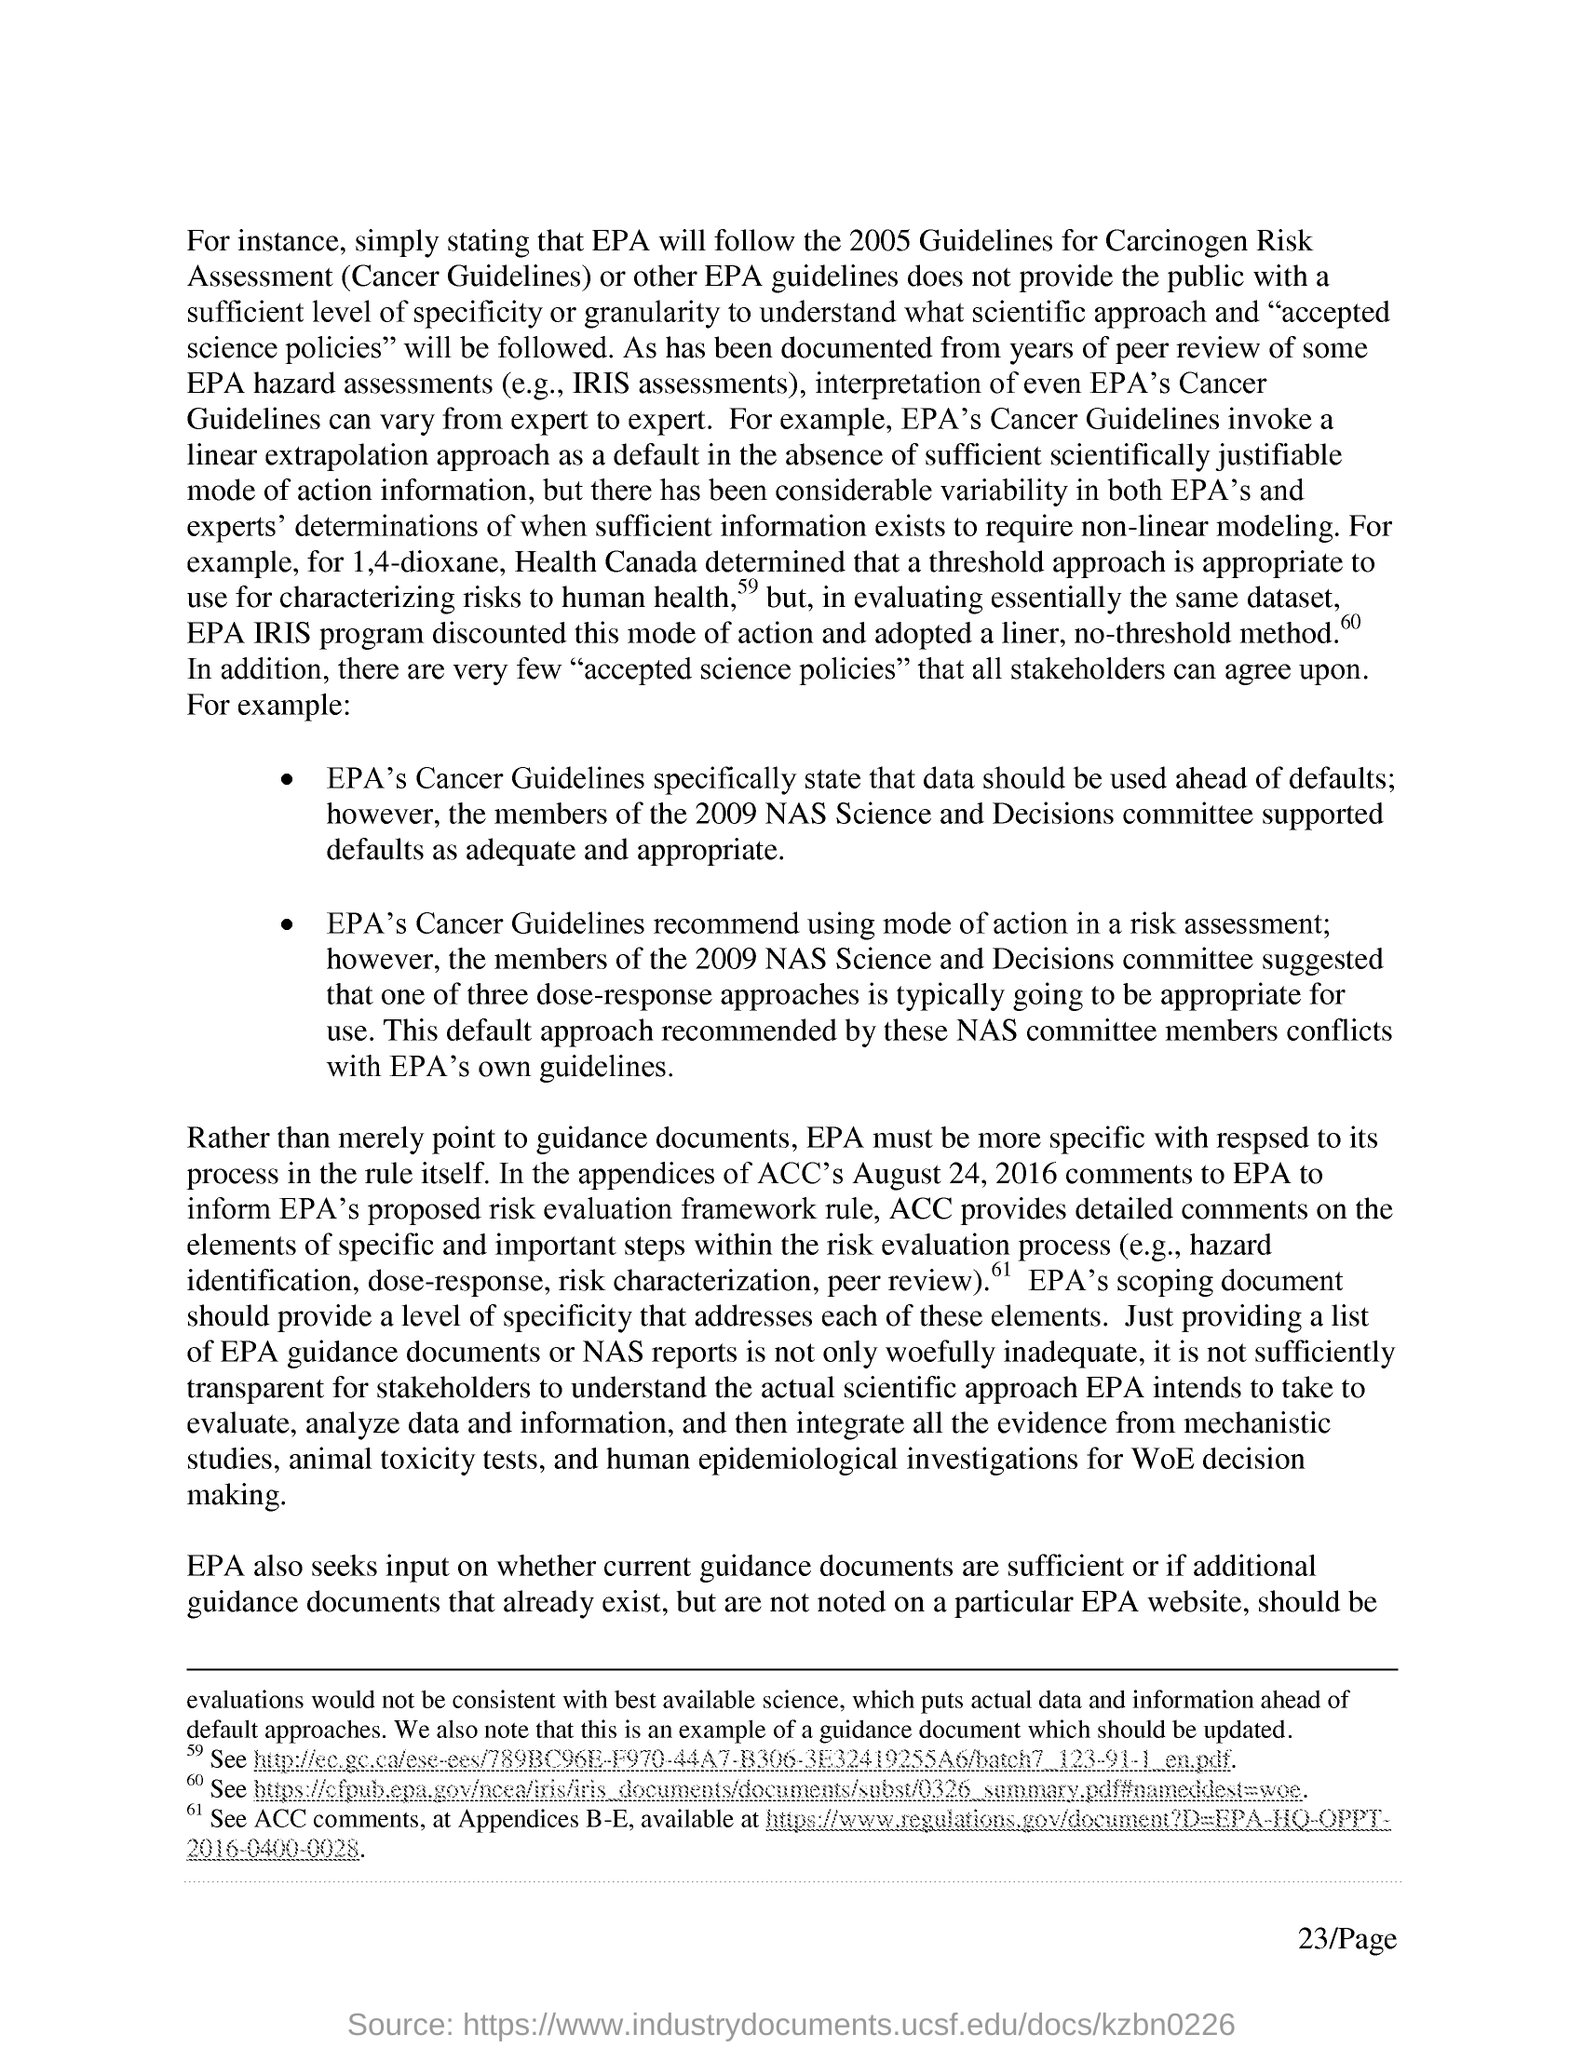What is the Page Number?
Make the answer very short. 23. 